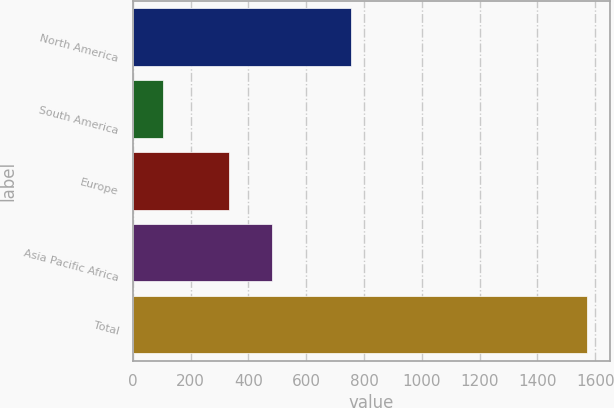Convert chart. <chart><loc_0><loc_0><loc_500><loc_500><bar_chart><fcel>North America<fcel>South America<fcel>Europe<fcel>Asia Pacific Africa<fcel>Total<nl><fcel>756<fcel>104<fcel>333<fcel>479.8<fcel>1572<nl></chart> 